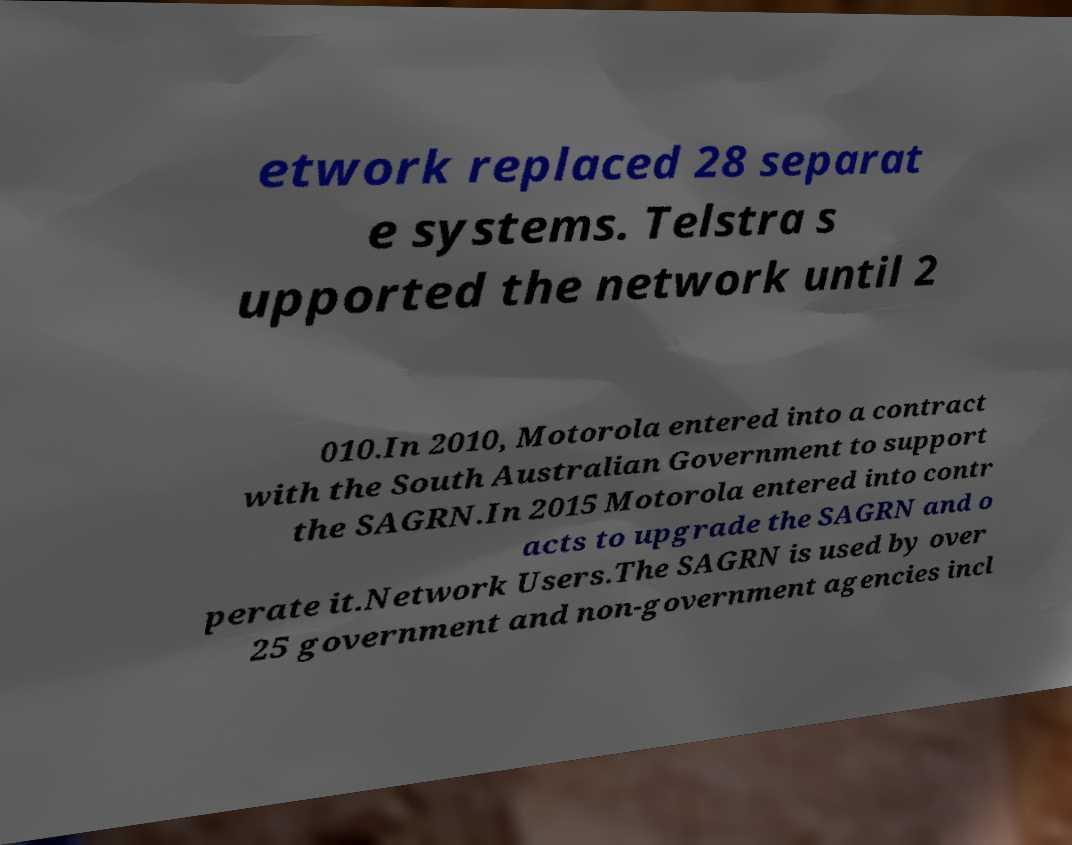Can you accurately transcribe the text from the provided image for me? etwork replaced 28 separat e systems. Telstra s upported the network until 2 010.In 2010, Motorola entered into a contract with the South Australian Government to support the SAGRN.In 2015 Motorola entered into contr acts to upgrade the SAGRN and o perate it.Network Users.The SAGRN is used by over 25 government and non-government agencies incl 